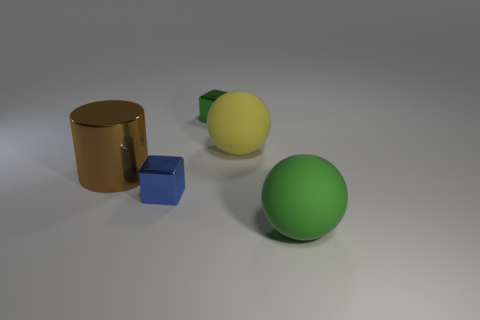What shape is the yellow thing?
Offer a very short reply. Sphere. What number of tiny objects are either blue objects or shiny things?
Your answer should be compact. 2. There is another rubber object that is the same shape as the big yellow rubber thing; what size is it?
Your answer should be compact. Large. What number of objects are both behind the big brown cylinder and to the right of the tiny green metal block?
Provide a succinct answer. 1. There is a blue metal thing; is its shape the same as the green thing that is to the right of the yellow object?
Offer a very short reply. No. Is the number of brown cylinders that are left of the green shiny block greater than the number of large blue rubber cylinders?
Make the answer very short. Yes. Is the number of tiny green objects in front of the green metal thing less than the number of blue metal things?
Provide a short and direct response. Yes. What material is the object that is both left of the yellow object and behind the big brown metallic thing?
Your answer should be very brief. Metal. There is a small thing in front of the tiny green shiny cube; is its color the same as the tiny metal object that is behind the big cylinder?
Keep it short and to the point. No. What number of cyan things are either large balls or cubes?
Your answer should be compact. 0. 